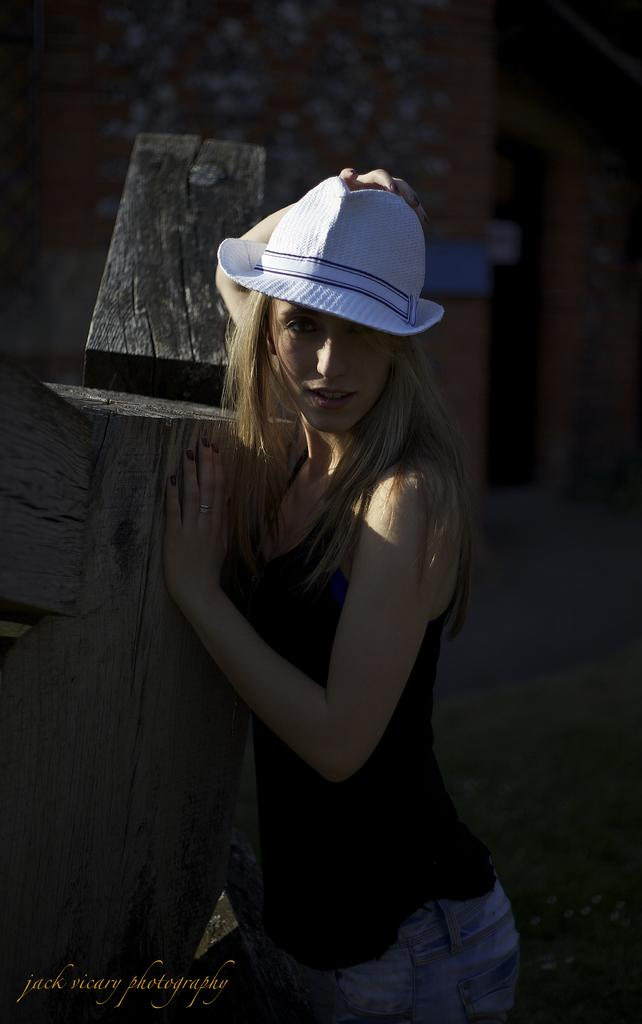What is the main subject of the image? There is a person in the image. What is the person wearing in the image? The person is wearing a cap in the image. What is the person doing in the image? The person is posing for a photo in the image. What is the color of the background in the image? The background of the image is dark. What type of wave can be seen crashing on the shore in the image? There is no wave or shore present in the image; it features a person posing for a photo with a dark background. What authority figure is depicted in the image? There is no authority figure present in the image; it features a person wearing a cap and posing for a photo. 